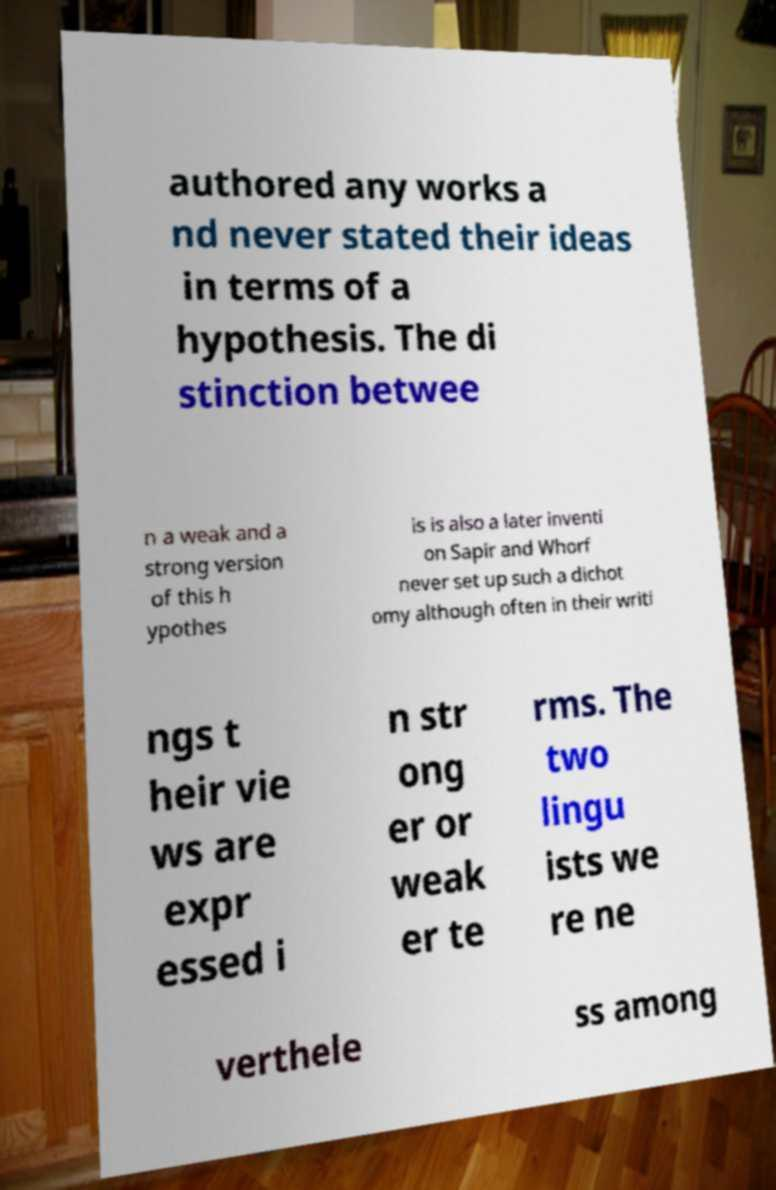What messages or text are displayed in this image? I need them in a readable, typed format. authored any works a nd never stated their ideas in terms of a hypothesis. The di stinction betwee n a weak and a strong version of this h ypothes is is also a later inventi on Sapir and Whorf never set up such a dichot omy although often in their writi ngs t heir vie ws are expr essed i n str ong er or weak er te rms. The two lingu ists we re ne verthele ss among 